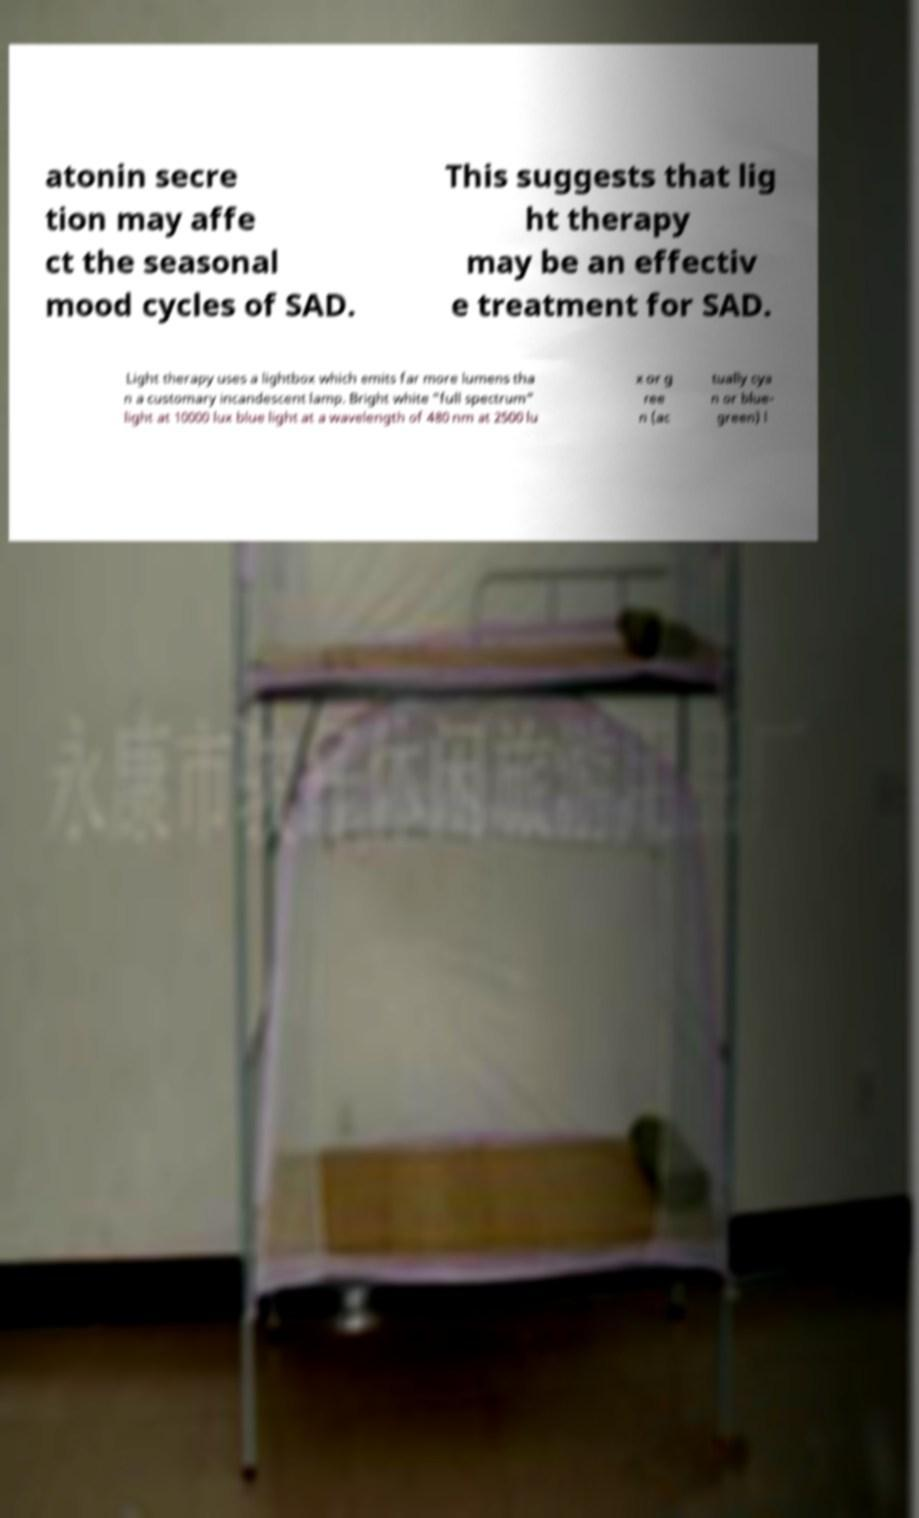I need the written content from this picture converted into text. Can you do that? atonin secre tion may affe ct the seasonal mood cycles of SAD. This suggests that lig ht therapy may be an effectiv e treatment for SAD. Light therapy uses a lightbox which emits far more lumens tha n a customary incandescent lamp. Bright white "full spectrum" light at 10000 lux blue light at a wavelength of 480 nm at 2500 lu x or g ree n (ac tually cya n or blue- green) l 